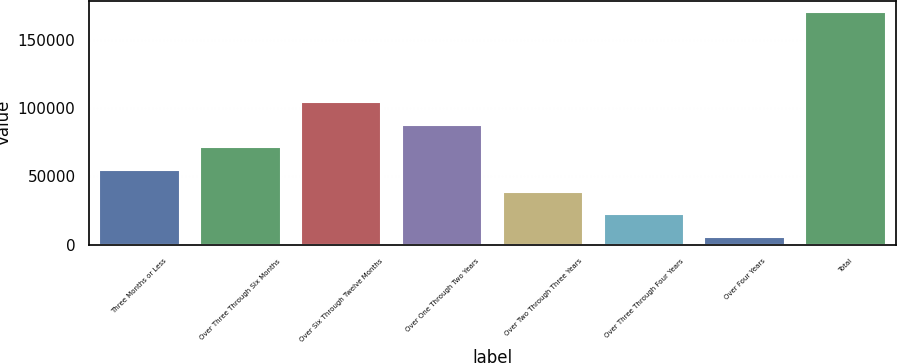Convert chart. <chart><loc_0><loc_0><loc_500><loc_500><bar_chart><fcel>Three Months or Less<fcel>Over Three Through Six Months<fcel>Over Six Through Twelve Months<fcel>Over One Through Two Years<fcel>Over Two Through Three Years<fcel>Over Three Through Four Years<fcel>Over Four Years<fcel>Total<nl><fcel>55019.6<fcel>71454.8<fcel>104325<fcel>87890<fcel>38584.4<fcel>22149.2<fcel>5714<fcel>170066<nl></chart> 